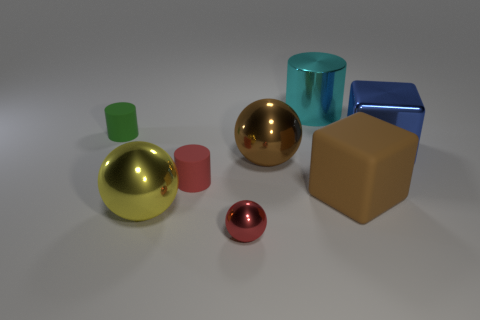Add 1 green objects. How many objects exist? 9 Subtract all cubes. How many objects are left? 6 Add 3 brown matte blocks. How many brown matte blocks are left? 4 Add 6 yellow metallic spheres. How many yellow metallic spheres exist? 7 Subtract 1 cyan cylinders. How many objects are left? 7 Subtract all metallic cylinders. Subtract all red spheres. How many objects are left? 6 